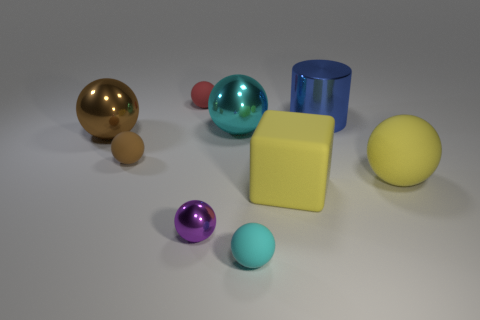How many big things are either brown rubber balls or blue things?
Offer a very short reply. 1. Are there an equal number of small cyan rubber spheres behind the small purple ball and metallic objects?
Keep it short and to the point. No. There is a blue cylinder; are there any large metallic spheres in front of it?
Offer a terse response. Yes. How many matte objects are either tiny purple things or cyan cylinders?
Provide a short and direct response. 0. There is a tiny cyan thing; how many cubes are on the left side of it?
Your answer should be very brief. 0. Are there any cyan matte spheres of the same size as the blue metal cylinder?
Your answer should be very brief. No. Is there a metal cylinder of the same color as the tiny shiny object?
Your answer should be very brief. No. Is there anything else that is the same size as the red matte thing?
Provide a short and direct response. Yes. How many big shiny things are the same color as the small metal object?
Offer a terse response. 0. Is the color of the tiny shiny ball the same as the big matte thing that is right of the block?
Provide a short and direct response. No. 